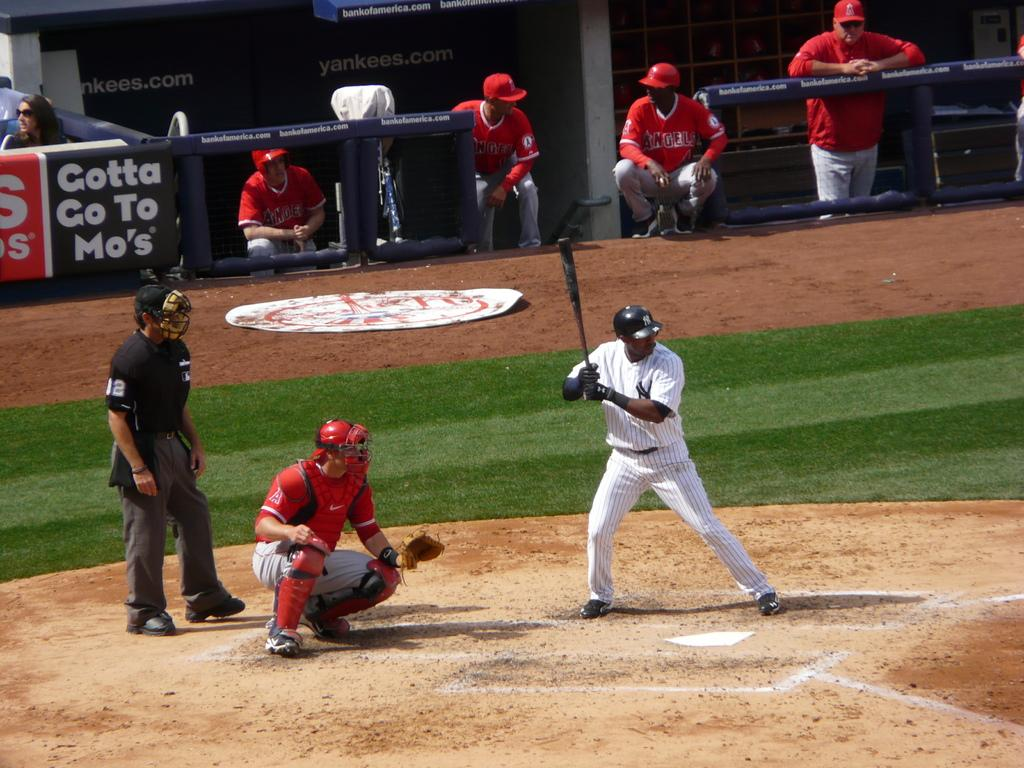Provide a one-sentence caption for the provided image. A New York Yankees player is about to bat. 